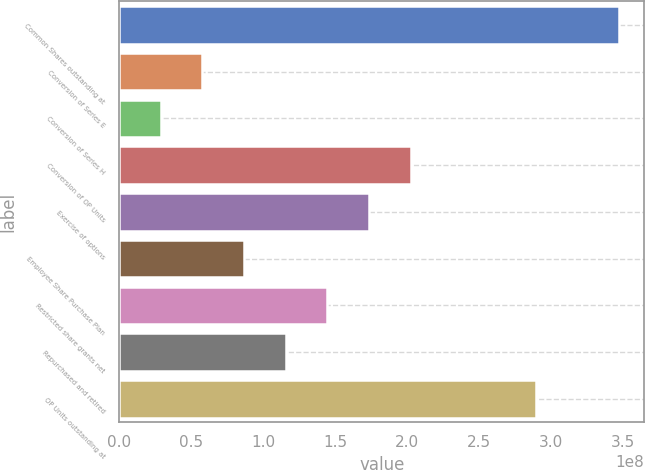Convert chart to OTSL. <chart><loc_0><loc_0><loc_500><loc_500><bar_chart><fcel>Common Shares outstanding at<fcel>Conversion of Series E<fcel>Conversion of Series H<fcel>Conversion of OP Units<fcel>Exercise of options<fcel>Employee Share Purchase Plan<fcel>Restricted share grants net<fcel>Repurchased and retired<fcel>OP Units outstanding at<nl><fcel>3.4736e+08<fcel>5.78933e+07<fcel>2.89467e+07<fcel>2.02627e+08<fcel>1.7368e+08<fcel>8.684e+07<fcel>1.44733e+08<fcel>1.15787e+08<fcel>2.89467e+08<nl></chart> 